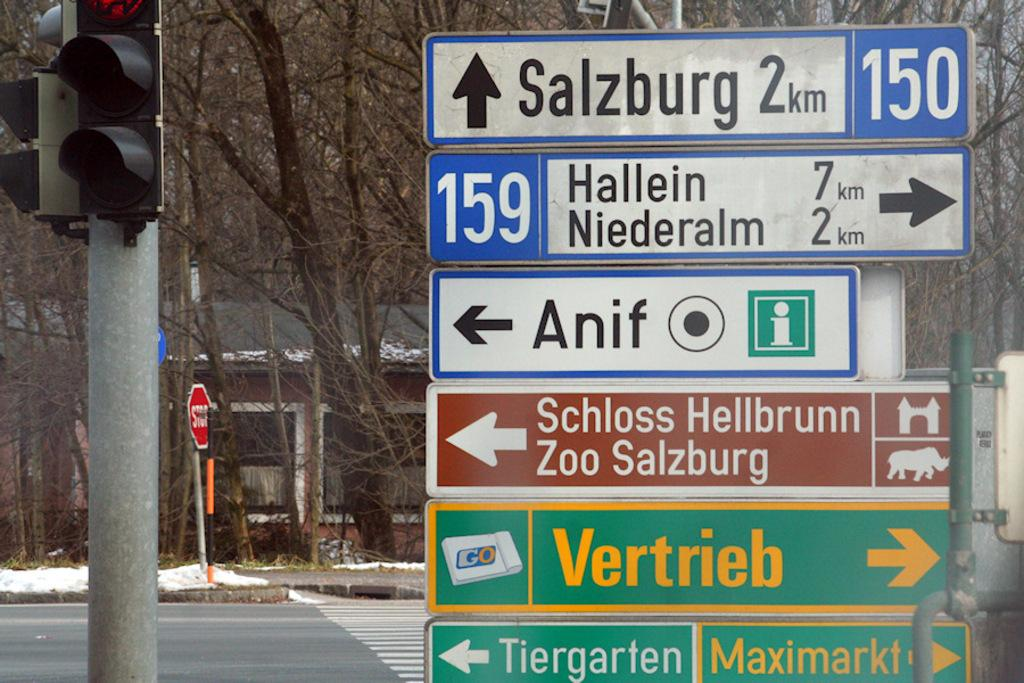<image>
Write a terse but informative summary of the picture. A collection of road signs, the top one reads Salzburg 2km. 